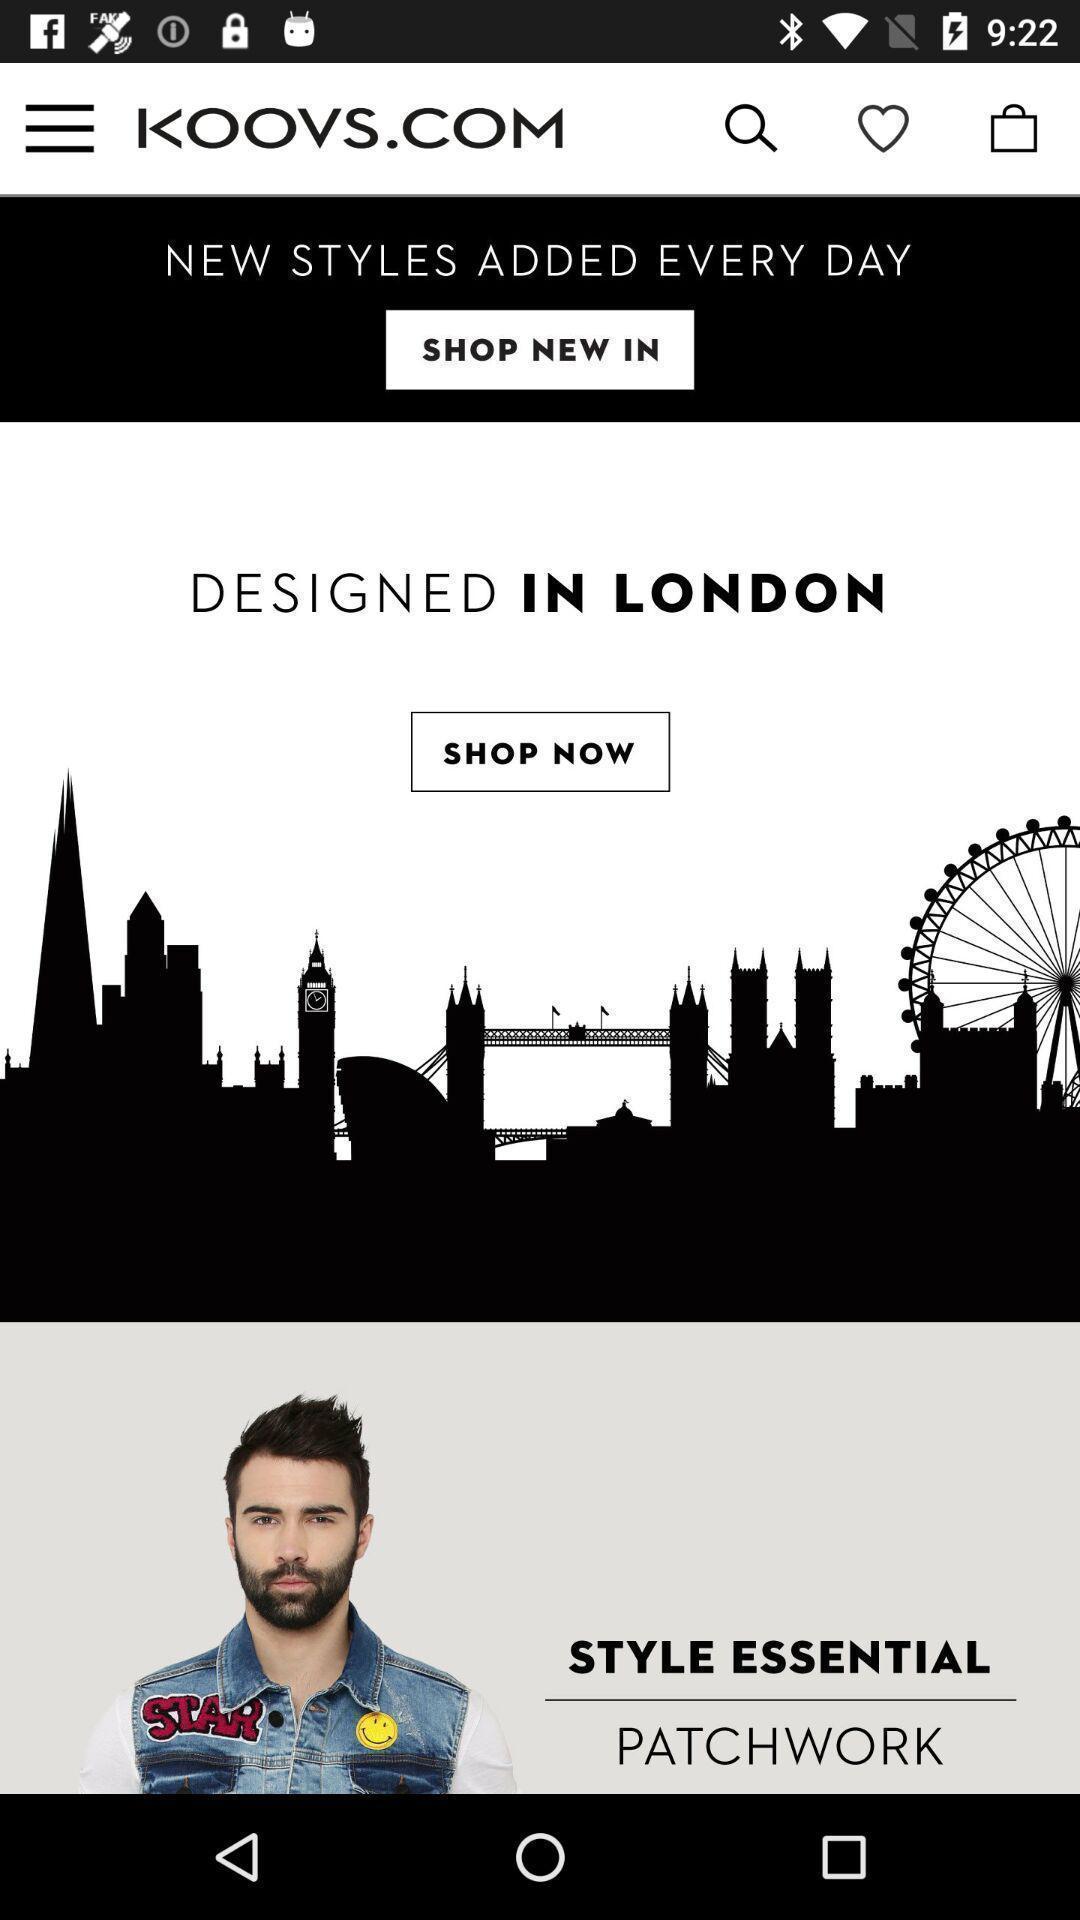Provide a description of this screenshot. Page showing new styles fashion app. 